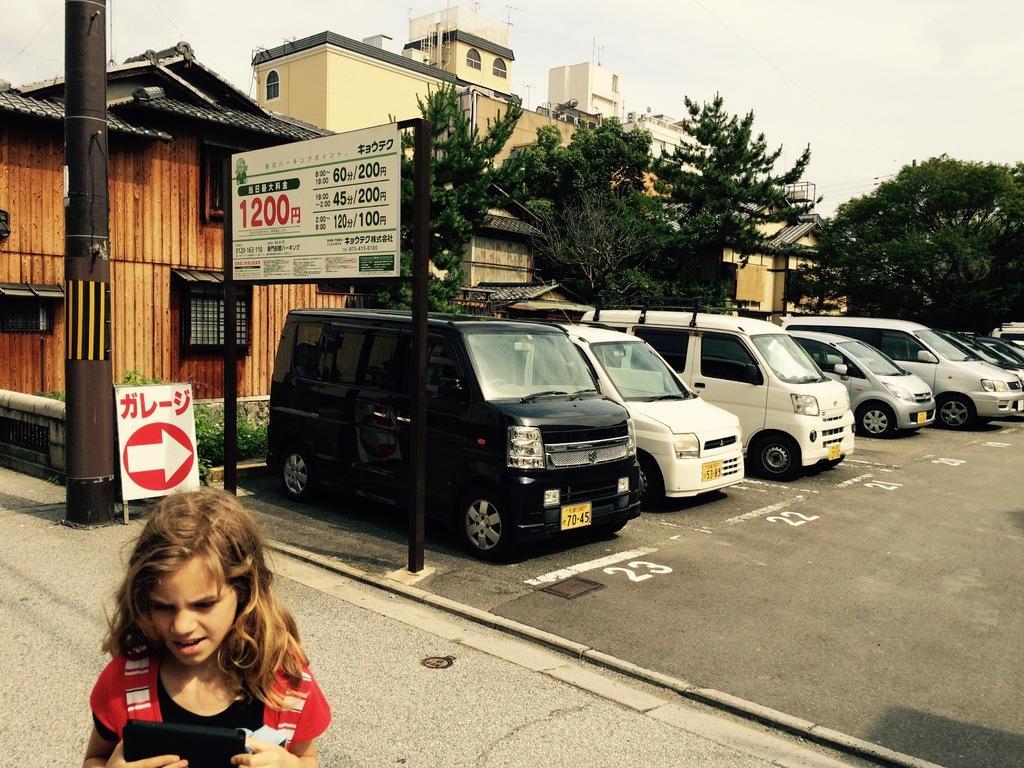Could you give a brief overview of what you see in this image? In this image we can see some buildings, trees, name boards, vehicles and other objects. In the background of the image there is the sky. At the bottom of the image there is the road, kid and an object. 